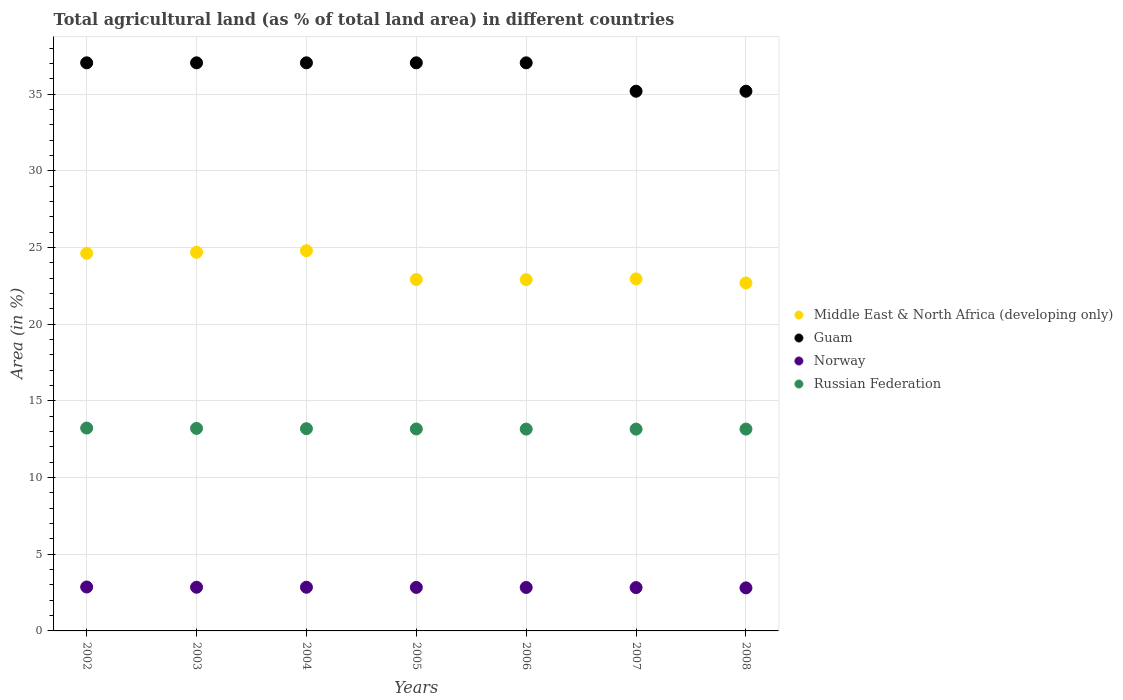How many different coloured dotlines are there?
Keep it short and to the point. 4. Is the number of dotlines equal to the number of legend labels?
Your answer should be compact. Yes. What is the percentage of agricultural land in Middle East & North Africa (developing only) in 2007?
Provide a succinct answer. 22.95. Across all years, what is the maximum percentage of agricultural land in Russian Federation?
Your answer should be compact. 13.23. Across all years, what is the minimum percentage of agricultural land in Guam?
Offer a terse response. 35.19. What is the total percentage of agricultural land in Norway in the graph?
Provide a short and direct response. 19.86. What is the difference between the percentage of agricultural land in Guam in 2003 and the percentage of agricultural land in Middle East & North Africa (developing only) in 2005?
Ensure brevity in your answer.  14.13. What is the average percentage of agricultural land in Middle East & North Africa (developing only) per year?
Offer a terse response. 23.65. In the year 2005, what is the difference between the percentage of agricultural land in Middle East & North Africa (developing only) and percentage of agricultural land in Norway?
Offer a very short reply. 20.07. What is the ratio of the percentage of agricultural land in Middle East & North Africa (developing only) in 2003 to that in 2005?
Provide a short and direct response. 1.08. What is the difference between the highest and the second highest percentage of agricultural land in Norway?
Ensure brevity in your answer.  0.02. What is the difference between the highest and the lowest percentage of agricultural land in Norway?
Your answer should be very brief. 0.06. In how many years, is the percentage of agricultural land in Russian Federation greater than the average percentage of agricultural land in Russian Federation taken over all years?
Your response must be concise. 3. Is the sum of the percentage of agricultural land in Guam in 2003 and 2008 greater than the maximum percentage of agricultural land in Russian Federation across all years?
Ensure brevity in your answer.  Yes. Is it the case that in every year, the sum of the percentage of agricultural land in Russian Federation and percentage of agricultural land in Middle East & North Africa (developing only)  is greater than the percentage of agricultural land in Guam?
Make the answer very short. No. Is the percentage of agricultural land in Norway strictly greater than the percentage of agricultural land in Russian Federation over the years?
Keep it short and to the point. No. How many years are there in the graph?
Your answer should be compact. 7. Are the values on the major ticks of Y-axis written in scientific E-notation?
Offer a very short reply. No. Does the graph contain any zero values?
Keep it short and to the point. No. Does the graph contain grids?
Your response must be concise. Yes. Where does the legend appear in the graph?
Provide a short and direct response. Center right. How many legend labels are there?
Your answer should be very brief. 4. What is the title of the graph?
Give a very brief answer. Total agricultural land (as % of total land area) in different countries. What is the label or title of the Y-axis?
Give a very brief answer. Area (in %). What is the Area (in %) in Middle East & North Africa (developing only) in 2002?
Your answer should be very brief. 24.62. What is the Area (in %) in Guam in 2002?
Provide a succinct answer. 37.04. What is the Area (in %) in Norway in 2002?
Your answer should be compact. 2.86. What is the Area (in %) in Russian Federation in 2002?
Give a very brief answer. 13.23. What is the Area (in %) in Middle East & North Africa (developing only) in 2003?
Give a very brief answer. 24.69. What is the Area (in %) of Guam in 2003?
Provide a short and direct response. 37.04. What is the Area (in %) in Norway in 2003?
Your answer should be very brief. 2.85. What is the Area (in %) in Russian Federation in 2003?
Make the answer very short. 13.2. What is the Area (in %) in Middle East & North Africa (developing only) in 2004?
Offer a very short reply. 24.79. What is the Area (in %) of Guam in 2004?
Provide a succinct answer. 37.04. What is the Area (in %) of Norway in 2004?
Keep it short and to the point. 2.85. What is the Area (in %) of Russian Federation in 2004?
Make the answer very short. 13.18. What is the Area (in %) in Middle East & North Africa (developing only) in 2005?
Provide a short and direct response. 22.91. What is the Area (in %) in Guam in 2005?
Offer a terse response. 37.04. What is the Area (in %) in Norway in 2005?
Your response must be concise. 2.84. What is the Area (in %) of Russian Federation in 2005?
Make the answer very short. 13.17. What is the Area (in %) in Middle East & North Africa (developing only) in 2006?
Ensure brevity in your answer.  22.9. What is the Area (in %) in Guam in 2006?
Offer a terse response. 37.04. What is the Area (in %) of Norway in 2006?
Give a very brief answer. 2.83. What is the Area (in %) of Russian Federation in 2006?
Offer a very short reply. 13.16. What is the Area (in %) in Middle East & North Africa (developing only) in 2007?
Your answer should be compact. 22.95. What is the Area (in %) of Guam in 2007?
Offer a terse response. 35.19. What is the Area (in %) in Norway in 2007?
Give a very brief answer. 2.83. What is the Area (in %) in Russian Federation in 2007?
Your answer should be compact. 13.16. What is the Area (in %) of Middle East & North Africa (developing only) in 2008?
Make the answer very short. 22.68. What is the Area (in %) of Guam in 2008?
Keep it short and to the point. 35.19. What is the Area (in %) in Norway in 2008?
Your answer should be compact. 2.81. What is the Area (in %) of Russian Federation in 2008?
Keep it short and to the point. 13.16. Across all years, what is the maximum Area (in %) in Middle East & North Africa (developing only)?
Your answer should be compact. 24.79. Across all years, what is the maximum Area (in %) in Guam?
Keep it short and to the point. 37.04. Across all years, what is the maximum Area (in %) in Norway?
Your answer should be compact. 2.86. Across all years, what is the maximum Area (in %) of Russian Federation?
Provide a short and direct response. 13.23. Across all years, what is the minimum Area (in %) in Middle East & North Africa (developing only)?
Give a very brief answer. 22.68. Across all years, what is the minimum Area (in %) of Guam?
Give a very brief answer. 35.19. Across all years, what is the minimum Area (in %) in Norway?
Your response must be concise. 2.81. Across all years, what is the minimum Area (in %) of Russian Federation?
Provide a short and direct response. 13.16. What is the total Area (in %) of Middle East & North Africa (developing only) in the graph?
Give a very brief answer. 165.54. What is the total Area (in %) in Guam in the graph?
Your answer should be very brief. 255.56. What is the total Area (in %) of Norway in the graph?
Your answer should be very brief. 19.86. What is the total Area (in %) of Russian Federation in the graph?
Make the answer very short. 92.25. What is the difference between the Area (in %) in Middle East & North Africa (developing only) in 2002 and that in 2003?
Give a very brief answer. -0.07. What is the difference between the Area (in %) in Guam in 2002 and that in 2003?
Offer a very short reply. 0. What is the difference between the Area (in %) of Norway in 2002 and that in 2003?
Ensure brevity in your answer.  0.02. What is the difference between the Area (in %) of Russian Federation in 2002 and that in 2003?
Your answer should be very brief. 0.02. What is the difference between the Area (in %) in Middle East & North Africa (developing only) in 2002 and that in 2004?
Your answer should be very brief. -0.17. What is the difference between the Area (in %) of Guam in 2002 and that in 2004?
Your answer should be compact. 0. What is the difference between the Area (in %) in Norway in 2002 and that in 2004?
Your answer should be compact. 0.02. What is the difference between the Area (in %) of Russian Federation in 2002 and that in 2004?
Ensure brevity in your answer.  0.04. What is the difference between the Area (in %) in Middle East & North Africa (developing only) in 2002 and that in 2005?
Ensure brevity in your answer.  1.71. What is the difference between the Area (in %) of Norway in 2002 and that in 2005?
Offer a terse response. 0.03. What is the difference between the Area (in %) in Russian Federation in 2002 and that in 2005?
Make the answer very short. 0.06. What is the difference between the Area (in %) in Middle East & North Africa (developing only) in 2002 and that in 2006?
Your answer should be compact. 1.72. What is the difference between the Area (in %) of Norway in 2002 and that in 2006?
Make the answer very short. 0.03. What is the difference between the Area (in %) of Russian Federation in 2002 and that in 2006?
Your answer should be compact. 0.07. What is the difference between the Area (in %) of Middle East & North Africa (developing only) in 2002 and that in 2007?
Keep it short and to the point. 1.67. What is the difference between the Area (in %) in Guam in 2002 and that in 2007?
Provide a succinct answer. 1.85. What is the difference between the Area (in %) in Norway in 2002 and that in 2007?
Provide a short and direct response. 0.04. What is the difference between the Area (in %) in Russian Federation in 2002 and that in 2007?
Make the answer very short. 0.07. What is the difference between the Area (in %) in Middle East & North Africa (developing only) in 2002 and that in 2008?
Offer a terse response. 1.93. What is the difference between the Area (in %) of Guam in 2002 and that in 2008?
Your answer should be very brief. 1.85. What is the difference between the Area (in %) of Norway in 2002 and that in 2008?
Make the answer very short. 0.06. What is the difference between the Area (in %) of Russian Federation in 2002 and that in 2008?
Keep it short and to the point. 0.07. What is the difference between the Area (in %) in Middle East & North Africa (developing only) in 2003 and that in 2004?
Your answer should be very brief. -0.1. What is the difference between the Area (in %) of Russian Federation in 2003 and that in 2004?
Your answer should be very brief. 0.02. What is the difference between the Area (in %) in Middle East & North Africa (developing only) in 2003 and that in 2005?
Give a very brief answer. 1.78. What is the difference between the Area (in %) of Guam in 2003 and that in 2005?
Your answer should be very brief. 0. What is the difference between the Area (in %) in Norway in 2003 and that in 2005?
Provide a short and direct response. 0.01. What is the difference between the Area (in %) of Russian Federation in 2003 and that in 2005?
Keep it short and to the point. 0.04. What is the difference between the Area (in %) of Middle East & North Africa (developing only) in 2003 and that in 2006?
Keep it short and to the point. 1.79. What is the difference between the Area (in %) in Guam in 2003 and that in 2006?
Offer a terse response. 0. What is the difference between the Area (in %) in Norway in 2003 and that in 2006?
Your response must be concise. 0.01. What is the difference between the Area (in %) in Russian Federation in 2003 and that in 2006?
Your answer should be very brief. 0.05. What is the difference between the Area (in %) in Middle East & North Africa (developing only) in 2003 and that in 2007?
Offer a terse response. 1.74. What is the difference between the Area (in %) of Guam in 2003 and that in 2007?
Give a very brief answer. 1.85. What is the difference between the Area (in %) in Norway in 2003 and that in 2007?
Make the answer very short. 0.02. What is the difference between the Area (in %) in Russian Federation in 2003 and that in 2007?
Make the answer very short. 0.05. What is the difference between the Area (in %) of Middle East & North Africa (developing only) in 2003 and that in 2008?
Keep it short and to the point. 2. What is the difference between the Area (in %) of Guam in 2003 and that in 2008?
Provide a succinct answer. 1.85. What is the difference between the Area (in %) of Norway in 2003 and that in 2008?
Your answer should be compact. 0.04. What is the difference between the Area (in %) in Russian Federation in 2003 and that in 2008?
Provide a succinct answer. 0.04. What is the difference between the Area (in %) in Middle East & North Africa (developing only) in 2004 and that in 2005?
Keep it short and to the point. 1.88. What is the difference between the Area (in %) in Norway in 2004 and that in 2005?
Your answer should be compact. 0.01. What is the difference between the Area (in %) in Russian Federation in 2004 and that in 2005?
Your answer should be compact. 0.02. What is the difference between the Area (in %) of Middle East & North Africa (developing only) in 2004 and that in 2006?
Offer a terse response. 1.89. What is the difference between the Area (in %) in Guam in 2004 and that in 2006?
Provide a short and direct response. 0. What is the difference between the Area (in %) in Norway in 2004 and that in 2006?
Keep it short and to the point. 0.01. What is the difference between the Area (in %) in Russian Federation in 2004 and that in 2006?
Keep it short and to the point. 0.03. What is the difference between the Area (in %) in Middle East & North Africa (developing only) in 2004 and that in 2007?
Your response must be concise. 1.84. What is the difference between the Area (in %) in Guam in 2004 and that in 2007?
Provide a succinct answer. 1.85. What is the difference between the Area (in %) in Norway in 2004 and that in 2007?
Provide a succinct answer. 0.02. What is the difference between the Area (in %) in Russian Federation in 2004 and that in 2007?
Your answer should be very brief. 0.03. What is the difference between the Area (in %) in Middle East & North Africa (developing only) in 2004 and that in 2008?
Give a very brief answer. 2.1. What is the difference between the Area (in %) of Guam in 2004 and that in 2008?
Your answer should be very brief. 1.85. What is the difference between the Area (in %) of Norway in 2004 and that in 2008?
Offer a terse response. 0.04. What is the difference between the Area (in %) of Russian Federation in 2004 and that in 2008?
Provide a short and direct response. 0.03. What is the difference between the Area (in %) in Middle East & North Africa (developing only) in 2005 and that in 2006?
Give a very brief answer. 0.01. What is the difference between the Area (in %) of Norway in 2005 and that in 2006?
Make the answer very short. 0. What is the difference between the Area (in %) of Russian Federation in 2005 and that in 2006?
Offer a terse response. 0.01. What is the difference between the Area (in %) in Middle East & North Africa (developing only) in 2005 and that in 2007?
Keep it short and to the point. -0.04. What is the difference between the Area (in %) of Guam in 2005 and that in 2007?
Make the answer very short. 1.85. What is the difference between the Area (in %) in Norway in 2005 and that in 2007?
Your answer should be compact. 0.01. What is the difference between the Area (in %) in Russian Federation in 2005 and that in 2007?
Provide a succinct answer. 0.01. What is the difference between the Area (in %) in Middle East & North Africa (developing only) in 2005 and that in 2008?
Provide a short and direct response. 0.23. What is the difference between the Area (in %) of Guam in 2005 and that in 2008?
Keep it short and to the point. 1.85. What is the difference between the Area (in %) in Norway in 2005 and that in 2008?
Give a very brief answer. 0.03. What is the difference between the Area (in %) of Russian Federation in 2005 and that in 2008?
Keep it short and to the point. 0.01. What is the difference between the Area (in %) in Middle East & North Africa (developing only) in 2006 and that in 2007?
Keep it short and to the point. -0.05. What is the difference between the Area (in %) of Guam in 2006 and that in 2007?
Ensure brevity in your answer.  1.85. What is the difference between the Area (in %) of Norway in 2006 and that in 2007?
Your answer should be very brief. 0.01. What is the difference between the Area (in %) in Russian Federation in 2006 and that in 2007?
Your answer should be compact. 0. What is the difference between the Area (in %) in Middle East & North Africa (developing only) in 2006 and that in 2008?
Make the answer very short. 0.22. What is the difference between the Area (in %) in Guam in 2006 and that in 2008?
Provide a short and direct response. 1.85. What is the difference between the Area (in %) of Norway in 2006 and that in 2008?
Offer a very short reply. 0.03. What is the difference between the Area (in %) in Russian Federation in 2006 and that in 2008?
Offer a very short reply. -0. What is the difference between the Area (in %) in Middle East & North Africa (developing only) in 2007 and that in 2008?
Ensure brevity in your answer.  0.27. What is the difference between the Area (in %) in Norway in 2007 and that in 2008?
Your response must be concise. 0.02. What is the difference between the Area (in %) in Russian Federation in 2007 and that in 2008?
Offer a terse response. -0. What is the difference between the Area (in %) in Middle East & North Africa (developing only) in 2002 and the Area (in %) in Guam in 2003?
Offer a very short reply. -12.42. What is the difference between the Area (in %) in Middle East & North Africa (developing only) in 2002 and the Area (in %) in Norway in 2003?
Give a very brief answer. 21.77. What is the difference between the Area (in %) of Middle East & North Africa (developing only) in 2002 and the Area (in %) of Russian Federation in 2003?
Offer a terse response. 11.41. What is the difference between the Area (in %) in Guam in 2002 and the Area (in %) in Norway in 2003?
Give a very brief answer. 34.19. What is the difference between the Area (in %) in Guam in 2002 and the Area (in %) in Russian Federation in 2003?
Your answer should be compact. 23.83. What is the difference between the Area (in %) in Norway in 2002 and the Area (in %) in Russian Federation in 2003?
Keep it short and to the point. -10.34. What is the difference between the Area (in %) in Middle East & North Africa (developing only) in 2002 and the Area (in %) in Guam in 2004?
Ensure brevity in your answer.  -12.42. What is the difference between the Area (in %) in Middle East & North Africa (developing only) in 2002 and the Area (in %) in Norway in 2004?
Offer a terse response. 21.77. What is the difference between the Area (in %) of Middle East & North Africa (developing only) in 2002 and the Area (in %) of Russian Federation in 2004?
Offer a very short reply. 11.43. What is the difference between the Area (in %) in Guam in 2002 and the Area (in %) in Norway in 2004?
Offer a very short reply. 34.19. What is the difference between the Area (in %) of Guam in 2002 and the Area (in %) of Russian Federation in 2004?
Keep it short and to the point. 23.85. What is the difference between the Area (in %) in Norway in 2002 and the Area (in %) in Russian Federation in 2004?
Your answer should be compact. -10.32. What is the difference between the Area (in %) of Middle East & North Africa (developing only) in 2002 and the Area (in %) of Guam in 2005?
Make the answer very short. -12.42. What is the difference between the Area (in %) of Middle East & North Africa (developing only) in 2002 and the Area (in %) of Norway in 2005?
Offer a terse response. 21.78. What is the difference between the Area (in %) in Middle East & North Africa (developing only) in 2002 and the Area (in %) in Russian Federation in 2005?
Your response must be concise. 11.45. What is the difference between the Area (in %) of Guam in 2002 and the Area (in %) of Norway in 2005?
Offer a terse response. 34.2. What is the difference between the Area (in %) of Guam in 2002 and the Area (in %) of Russian Federation in 2005?
Your answer should be compact. 23.87. What is the difference between the Area (in %) of Norway in 2002 and the Area (in %) of Russian Federation in 2005?
Your answer should be compact. -10.3. What is the difference between the Area (in %) in Middle East & North Africa (developing only) in 2002 and the Area (in %) in Guam in 2006?
Offer a very short reply. -12.42. What is the difference between the Area (in %) in Middle East & North Africa (developing only) in 2002 and the Area (in %) in Norway in 2006?
Provide a short and direct response. 21.78. What is the difference between the Area (in %) of Middle East & North Africa (developing only) in 2002 and the Area (in %) of Russian Federation in 2006?
Your response must be concise. 11.46. What is the difference between the Area (in %) in Guam in 2002 and the Area (in %) in Norway in 2006?
Offer a very short reply. 34.2. What is the difference between the Area (in %) of Guam in 2002 and the Area (in %) of Russian Federation in 2006?
Give a very brief answer. 23.88. What is the difference between the Area (in %) in Norway in 2002 and the Area (in %) in Russian Federation in 2006?
Your response must be concise. -10.29. What is the difference between the Area (in %) in Middle East & North Africa (developing only) in 2002 and the Area (in %) in Guam in 2007?
Provide a short and direct response. -10.57. What is the difference between the Area (in %) of Middle East & North Africa (developing only) in 2002 and the Area (in %) of Norway in 2007?
Make the answer very short. 21.79. What is the difference between the Area (in %) in Middle East & North Africa (developing only) in 2002 and the Area (in %) in Russian Federation in 2007?
Provide a short and direct response. 11.46. What is the difference between the Area (in %) of Guam in 2002 and the Area (in %) of Norway in 2007?
Give a very brief answer. 34.21. What is the difference between the Area (in %) of Guam in 2002 and the Area (in %) of Russian Federation in 2007?
Your response must be concise. 23.88. What is the difference between the Area (in %) in Norway in 2002 and the Area (in %) in Russian Federation in 2007?
Make the answer very short. -10.29. What is the difference between the Area (in %) of Middle East & North Africa (developing only) in 2002 and the Area (in %) of Guam in 2008?
Your answer should be compact. -10.57. What is the difference between the Area (in %) of Middle East & North Africa (developing only) in 2002 and the Area (in %) of Norway in 2008?
Give a very brief answer. 21.81. What is the difference between the Area (in %) in Middle East & North Africa (developing only) in 2002 and the Area (in %) in Russian Federation in 2008?
Your answer should be very brief. 11.46. What is the difference between the Area (in %) in Guam in 2002 and the Area (in %) in Norway in 2008?
Offer a terse response. 34.23. What is the difference between the Area (in %) in Guam in 2002 and the Area (in %) in Russian Federation in 2008?
Provide a short and direct response. 23.88. What is the difference between the Area (in %) in Norway in 2002 and the Area (in %) in Russian Federation in 2008?
Give a very brief answer. -10.29. What is the difference between the Area (in %) in Middle East & North Africa (developing only) in 2003 and the Area (in %) in Guam in 2004?
Give a very brief answer. -12.35. What is the difference between the Area (in %) in Middle East & North Africa (developing only) in 2003 and the Area (in %) in Norway in 2004?
Your response must be concise. 21.84. What is the difference between the Area (in %) of Middle East & North Africa (developing only) in 2003 and the Area (in %) of Russian Federation in 2004?
Your response must be concise. 11.5. What is the difference between the Area (in %) of Guam in 2003 and the Area (in %) of Norway in 2004?
Make the answer very short. 34.19. What is the difference between the Area (in %) of Guam in 2003 and the Area (in %) of Russian Federation in 2004?
Offer a terse response. 23.85. What is the difference between the Area (in %) in Norway in 2003 and the Area (in %) in Russian Federation in 2004?
Provide a short and direct response. -10.34. What is the difference between the Area (in %) in Middle East & North Africa (developing only) in 2003 and the Area (in %) in Guam in 2005?
Offer a very short reply. -12.35. What is the difference between the Area (in %) of Middle East & North Africa (developing only) in 2003 and the Area (in %) of Norway in 2005?
Ensure brevity in your answer.  21.85. What is the difference between the Area (in %) in Middle East & North Africa (developing only) in 2003 and the Area (in %) in Russian Federation in 2005?
Provide a succinct answer. 11.52. What is the difference between the Area (in %) in Guam in 2003 and the Area (in %) in Norway in 2005?
Provide a short and direct response. 34.2. What is the difference between the Area (in %) of Guam in 2003 and the Area (in %) of Russian Federation in 2005?
Your response must be concise. 23.87. What is the difference between the Area (in %) in Norway in 2003 and the Area (in %) in Russian Federation in 2005?
Provide a short and direct response. -10.32. What is the difference between the Area (in %) in Middle East & North Africa (developing only) in 2003 and the Area (in %) in Guam in 2006?
Offer a very short reply. -12.35. What is the difference between the Area (in %) of Middle East & North Africa (developing only) in 2003 and the Area (in %) of Norway in 2006?
Provide a short and direct response. 21.85. What is the difference between the Area (in %) in Middle East & North Africa (developing only) in 2003 and the Area (in %) in Russian Federation in 2006?
Provide a succinct answer. 11.53. What is the difference between the Area (in %) of Guam in 2003 and the Area (in %) of Norway in 2006?
Provide a succinct answer. 34.2. What is the difference between the Area (in %) in Guam in 2003 and the Area (in %) in Russian Federation in 2006?
Offer a very short reply. 23.88. What is the difference between the Area (in %) of Norway in 2003 and the Area (in %) of Russian Federation in 2006?
Your response must be concise. -10.31. What is the difference between the Area (in %) in Middle East & North Africa (developing only) in 2003 and the Area (in %) in Guam in 2007?
Give a very brief answer. -10.5. What is the difference between the Area (in %) of Middle East & North Africa (developing only) in 2003 and the Area (in %) of Norway in 2007?
Provide a short and direct response. 21.86. What is the difference between the Area (in %) in Middle East & North Africa (developing only) in 2003 and the Area (in %) in Russian Federation in 2007?
Keep it short and to the point. 11.53. What is the difference between the Area (in %) of Guam in 2003 and the Area (in %) of Norway in 2007?
Your response must be concise. 34.21. What is the difference between the Area (in %) of Guam in 2003 and the Area (in %) of Russian Federation in 2007?
Offer a very short reply. 23.88. What is the difference between the Area (in %) of Norway in 2003 and the Area (in %) of Russian Federation in 2007?
Provide a short and direct response. -10.31. What is the difference between the Area (in %) of Middle East & North Africa (developing only) in 2003 and the Area (in %) of Guam in 2008?
Your answer should be very brief. -10.5. What is the difference between the Area (in %) of Middle East & North Africa (developing only) in 2003 and the Area (in %) of Norway in 2008?
Provide a short and direct response. 21.88. What is the difference between the Area (in %) in Middle East & North Africa (developing only) in 2003 and the Area (in %) in Russian Federation in 2008?
Give a very brief answer. 11.53. What is the difference between the Area (in %) in Guam in 2003 and the Area (in %) in Norway in 2008?
Provide a succinct answer. 34.23. What is the difference between the Area (in %) of Guam in 2003 and the Area (in %) of Russian Federation in 2008?
Ensure brevity in your answer.  23.88. What is the difference between the Area (in %) in Norway in 2003 and the Area (in %) in Russian Federation in 2008?
Provide a succinct answer. -10.31. What is the difference between the Area (in %) of Middle East & North Africa (developing only) in 2004 and the Area (in %) of Guam in 2005?
Offer a terse response. -12.25. What is the difference between the Area (in %) of Middle East & North Africa (developing only) in 2004 and the Area (in %) of Norway in 2005?
Ensure brevity in your answer.  21.95. What is the difference between the Area (in %) in Middle East & North Africa (developing only) in 2004 and the Area (in %) in Russian Federation in 2005?
Offer a terse response. 11.62. What is the difference between the Area (in %) of Guam in 2004 and the Area (in %) of Norway in 2005?
Your answer should be compact. 34.2. What is the difference between the Area (in %) in Guam in 2004 and the Area (in %) in Russian Federation in 2005?
Provide a succinct answer. 23.87. What is the difference between the Area (in %) in Norway in 2004 and the Area (in %) in Russian Federation in 2005?
Provide a succinct answer. -10.32. What is the difference between the Area (in %) of Middle East & North Africa (developing only) in 2004 and the Area (in %) of Guam in 2006?
Give a very brief answer. -12.25. What is the difference between the Area (in %) of Middle East & North Africa (developing only) in 2004 and the Area (in %) of Norway in 2006?
Offer a terse response. 21.95. What is the difference between the Area (in %) of Middle East & North Africa (developing only) in 2004 and the Area (in %) of Russian Federation in 2006?
Keep it short and to the point. 11.63. What is the difference between the Area (in %) of Guam in 2004 and the Area (in %) of Norway in 2006?
Make the answer very short. 34.2. What is the difference between the Area (in %) of Guam in 2004 and the Area (in %) of Russian Federation in 2006?
Keep it short and to the point. 23.88. What is the difference between the Area (in %) in Norway in 2004 and the Area (in %) in Russian Federation in 2006?
Give a very brief answer. -10.31. What is the difference between the Area (in %) of Middle East & North Africa (developing only) in 2004 and the Area (in %) of Guam in 2007?
Make the answer very short. -10.4. What is the difference between the Area (in %) of Middle East & North Africa (developing only) in 2004 and the Area (in %) of Norway in 2007?
Offer a terse response. 21.96. What is the difference between the Area (in %) of Middle East & North Africa (developing only) in 2004 and the Area (in %) of Russian Federation in 2007?
Your answer should be compact. 11.63. What is the difference between the Area (in %) of Guam in 2004 and the Area (in %) of Norway in 2007?
Offer a terse response. 34.21. What is the difference between the Area (in %) of Guam in 2004 and the Area (in %) of Russian Federation in 2007?
Give a very brief answer. 23.88. What is the difference between the Area (in %) of Norway in 2004 and the Area (in %) of Russian Federation in 2007?
Make the answer very short. -10.31. What is the difference between the Area (in %) in Middle East & North Africa (developing only) in 2004 and the Area (in %) in Guam in 2008?
Your answer should be very brief. -10.4. What is the difference between the Area (in %) in Middle East & North Africa (developing only) in 2004 and the Area (in %) in Norway in 2008?
Your answer should be compact. 21.98. What is the difference between the Area (in %) in Middle East & North Africa (developing only) in 2004 and the Area (in %) in Russian Federation in 2008?
Give a very brief answer. 11.63. What is the difference between the Area (in %) in Guam in 2004 and the Area (in %) in Norway in 2008?
Your answer should be very brief. 34.23. What is the difference between the Area (in %) of Guam in 2004 and the Area (in %) of Russian Federation in 2008?
Provide a succinct answer. 23.88. What is the difference between the Area (in %) of Norway in 2004 and the Area (in %) of Russian Federation in 2008?
Offer a very short reply. -10.31. What is the difference between the Area (in %) in Middle East & North Africa (developing only) in 2005 and the Area (in %) in Guam in 2006?
Offer a very short reply. -14.13. What is the difference between the Area (in %) in Middle East & North Africa (developing only) in 2005 and the Area (in %) in Norway in 2006?
Your answer should be compact. 20.08. What is the difference between the Area (in %) of Middle East & North Africa (developing only) in 2005 and the Area (in %) of Russian Federation in 2006?
Make the answer very short. 9.75. What is the difference between the Area (in %) in Guam in 2005 and the Area (in %) in Norway in 2006?
Your response must be concise. 34.2. What is the difference between the Area (in %) in Guam in 2005 and the Area (in %) in Russian Federation in 2006?
Keep it short and to the point. 23.88. What is the difference between the Area (in %) in Norway in 2005 and the Area (in %) in Russian Federation in 2006?
Your answer should be compact. -10.32. What is the difference between the Area (in %) in Middle East & North Africa (developing only) in 2005 and the Area (in %) in Guam in 2007?
Your response must be concise. -12.27. What is the difference between the Area (in %) in Middle East & North Africa (developing only) in 2005 and the Area (in %) in Norway in 2007?
Provide a short and direct response. 20.09. What is the difference between the Area (in %) in Middle East & North Africa (developing only) in 2005 and the Area (in %) in Russian Federation in 2007?
Ensure brevity in your answer.  9.76. What is the difference between the Area (in %) of Guam in 2005 and the Area (in %) of Norway in 2007?
Your answer should be compact. 34.21. What is the difference between the Area (in %) of Guam in 2005 and the Area (in %) of Russian Federation in 2007?
Make the answer very short. 23.88. What is the difference between the Area (in %) of Norway in 2005 and the Area (in %) of Russian Federation in 2007?
Your response must be concise. -10.32. What is the difference between the Area (in %) in Middle East & North Africa (developing only) in 2005 and the Area (in %) in Guam in 2008?
Offer a very short reply. -12.27. What is the difference between the Area (in %) of Middle East & North Africa (developing only) in 2005 and the Area (in %) of Norway in 2008?
Provide a succinct answer. 20.11. What is the difference between the Area (in %) in Middle East & North Africa (developing only) in 2005 and the Area (in %) in Russian Federation in 2008?
Keep it short and to the point. 9.75. What is the difference between the Area (in %) in Guam in 2005 and the Area (in %) in Norway in 2008?
Your answer should be very brief. 34.23. What is the difference between the Area (in %) of Guam in 2005 and the Area (in %) of Russian Federation in 2008?
Ensure brevity in your answer.  23.88. What is the difference between the Area (in %) in Norway in 2005 and the Area (in %) in Russian Federation in 2008?
Ensure brevity in your answer.  -10.32. What is the difference between the Area (in %) in Middle East & North Africa (developing only) in 2006 and the Area (in %) in Guam in 2007?
Offer a very short reply. -12.28. What is the difference between the Area (in %) of Middle East & North Africa (developing only) in 2006 and the Area (in %) of Norway in 2007?
Keep it short and to the point. 20.08. What is the difference between the Area (in %) in Middle East & North Africa (developing only) in 2006 and the Area (in %) in Russian Federation in 2007?
Provide a succinct answer. 9.75. What is the difference between the Area (in %) in Guam in 2006 and the Area (in %) in Norway in 2007?
Give a very brief answer. 34.21. What is the difference between the Area (in %) of Guam in 2006 and the Area (in %) of Russian Federation in 2007?
Your response must be concise. 23.88. What is the difference between the Area (in %) in Norway in 2006 and the Area (in %) in Russian Federation in 2007?
Offer a very short reply. -10.32. What is the difference between the Area (in %) in Middle East & North Africa (developing only) in 2006 and the Area (in %) in Guam in 2008?
Provide a short and direct response. -12.28. What is the difference between the Area (in %) of Middle East & North Africa (developing only) in 2006 and the Area (in %) of Norway in 2008?
Keep it short and to the point. 20.1. What is the difference between the Area (in %) of Middle East & North Africa (developing only) in 2006 and the Area (in %) of Russian Federation in 2008?
Give a very brief answer. 9.74. What is the difference between the Area (in %) in Guam in 2006 and the Area (in %) in Norway in 2008?
Offer a terse response. 34.23. What is the difference between the Area (in %) in Guam in 2006 and the Area (in %) in Russian Federation in 2008?
Offer a very short reply. 23.88. What is the difference between the Area (in %) of Norway in 2006 and the Area (in %) of Russian Federation in 2008?
Your answer should be very brief. -10.32. What is the difference between the Area (in %) in Middle East & North Africa (developing only) in 2007 and the Area (in %) in Guam in 2008?
Ensure brevity in your answer.  -12.23. What is the difference between the Area (in %) of Middle East & North Africa (developing only) in 2007 and the Area (in %) of Norway in 2008?
Ensure brevity in your answer.  20.14. What is the difference between the Area (in %) in Middle East & North Africa (developing only) in 2007 and the Area (in %) in Russian Federation in 2008?
Keep it short and to the point. 9.79. What is the difference between the Area (in %) of Guam in 2007 and the Area (in %) of Norway in 2008?
Your answer should be compact. 32.38. What is the difference between the Area (in %) in Guam in 2007 and the Area (in %) in Russian Federation in 2008?
Your answer should be compact. 22.03. What is the difference between the Area (in %) in Norway in 2007 and the Area (in %) in Russian Federation in 2008?
Your answer should be compact. -10.33. What is the average Area (in %) in Middle East & North Africa (developing only) per year?
Provide a short and direct response. 23.65. What is the average Area (in %) of Guam per year?
Ensure brevity in your answer.  36.51. What is the average Area (in %) of Norway per year?
Offer a terse response. 2.84. What is the average Area (in %) of Russian Federation per year?
Make the answer very short. 13.18. In the year 2002, what is the difference between the Area (in %) in Middle East & North Africa (developing only) and Area (in %) in Guam?
Make the answer very short. -12.42. In the year 2002, what is the difference between the Area (in %) in Middle East & North Africa (developing only) and Area (in %) in Norway?
Make the answer very short. 21.75. In the year 2002, what is the difference between the Area (in %) in Middle East & North Africa (developing only) and Area (in %) in Russian Federation?
Ensure brevity in your answer.  11.39. In the year 2002, what is the difference between the Area (in %) in Guam and Area (in %) in Norway?
Ensure brevity in your answer.  34.17. In the year 2002, what is the difference between the Area (in %) of Guam and Area (in %) of Russian Federation?
Make the answer very short. 23.81. In the year 2002, what is the difference between the Area (in %) of Norway and Area (in %) of Russian Federation?
Your answer should be very brief. -10.36. In the year 2003, what is the difference between the Area (in %) in Middle East & North Africa (developing only) and Area (in %) in Guam?
Your answer should be compact. -12.35. In the year 2003, what is the difference between the Area (in %) in Middle East & North Africa (developing only) and Area (in %) in Norway?
Keep it short and to the point. 21.84. In the year 2003, what is the difference between the Area (in %) of Middle East & North Africa (developing only) and Area (in %) of Russian Federation?
Provide a short and direct response. 11.48. In the year 2003, what is the difference between the Area (in %) in Guam and Area (in %) in Norway?
Offer a terse response. 34.19. In the year 2003, what is the difference between the Area (in %) in Guam and Area (in %) in Russian Federation?
Give a very brief answer. 23.83. In the year 2003, what is the difference between the Area (in %) of Norway and Area (in %) of Russian Federation?
Offer a very short reply. -10.36. In the year 2004, what is the difference between the Area (in %) in Middle East & North Africa (developing only) and Area (in %) in Guam?
Provide a succinct answer. -12.25. In the year 2004, what is the difference between the Area (in %) in Middle East & North Africa (developing only) and Area (in %) in Norway?
Offer a very short reply. 21.94. In the year 2004, what is the difference between the Area (in %) in Middle East & North Africa (developing only) and Area (in %) in Russian Federation?
Your answer should be compact. 11.6. In the year 2004, what is the difference between the Area (in %) of Guam and Area (in %) of Norway?
Make the answer very short. 34.19. In the year 2004, what is the difference between the Area (in %) in Guam and Area (in %) in Russian Federation?
Your response must be concise. 23.85. In the year 2004, what is the difference between the Area (in %) in Norway and Area (in %) in Russian Federation?
Your response must be concise. -10.34. In the year 2005, what is the difference between the Area (in %) of Middle East & North Africa (developing only) and Area (in %) of Guam?
Ensure brevity in your answer.  -14.13. In the year 2005, what is the difference between the Area (in %) of Middle East & North Africa (developing only) and Area (in %) of Norway?
Offer a very short reply. 20.07. In the year 2005, what is the difference between the Area (in %) in Middle East & North Africa (developing only) and Area (in %) in Russian Federation?
Keep it short and to the point. 9.75. In the year 2005, what is the difference between the Area (in %) of Guam and Area (in %) of Norway?
Offer a terse response. 34.2. In the year 2005, what is the difference between the Area (in %) in Guam and Area (in %) in Russian Federation?
Give a very brief answer. 23.87. In the year 2005, what is the difference between the Area (in %) of Norway and Area (in %) of Russian Federation?
Your answer should be compact. -10.33. In the year 2006, what is the difference between the Area (in %) in Middle East & North Africa (developing only) and Area (in %) in Guam?
Provide a short and direct response. -14.14. In the year 2006, what is the difference between the Area (in %) of Middle East & North Africa (developing only) and Area (in %) of Norway?
Offer a very short reply. 20.07. In the year 2006, what is the difference between the Area (in %) in Middle East & North Africa (developing only) and Area (in %) in Russian Federation?
Your answer should be compact. 9.74. In the year 2006, what is the difference between the Area (in %) in Guam and Area (in %) in Norway?
Offer a terse response. 34.2. In the year 2006, what is the difference between the Area (in %) of Guam and Area (in %) of Russian Federation?
Provide a succinct answer. 23.88. In the year 2006, what is the difference between the Area (in %) in Norway and Area (in %) in Russian Federation?
Provide a succinct answer. -10.32. In the year 2007, what is the difference between the Area (in %) in Middle East & North Africa (developing only) and Area (in %) in Guam?
Your response must be concise. -12.23. In the year 2007, what is the difference between the Area (in %) in Middle East & North Africa (developing only) and Area (in %) in Norway?
Ensure brevity in your answer.  20.12. In the year 2007, what is the difference between the Area (in %) in Middle East & North Africa (developing only) and Area (in %) in Russian Federation?
Your answer should be very brief. 9.79. In the year 2007, what is the difference between the Area (in %) in Guam and Area (in %) in Norway?
Make the answer very short. 32.36. In the year 2007, what is the difference between the Area (in %) in Guam and Area (in %) in Russian Federation?
Your response must be concise. 22.03. In the year 2007, what is the difference between the Area (in %) of Norway and Area (in %) of Russian Federation?
Offer a terse response. -10.33. In the year 2008, what is the difference between the Area (in %) of Middle East & North Africa (developing only) and Area (in %) of Guam?
Provide a succinct answer. -12.5. In the year 2008, what is the difference between the Area (in %) of Middle East & North Africa (developing only) and Area (in %) of Norway?
Give a very brief answer. 19.88. In the year 2008, what is the difference between the Area (in %) of Middle East & North Africa (developing only) and Area (in %) of Russian Federation?
Provide a short and direct response. 9.53. In the year 2008, what is the difference between the Area (in %) of Guam and Area (in %) of Norway?
Your response must be concise. 32.38. In the year 2008, what is the difference between the Area (in %) in Guam and Area (in %) in Russian Federation?
Your answer should be very brief. 22.03. In the year 2008, what is the difference between the Area (in %) in Norway and Area (in %) in Russian Federation?
Offer a very short reply. -10.35. What is the ratio of the Area (in %) of Middle East & North Africa (developing only) in 2002 to that in 2003?
Your response must be concise. 1. What is the ratio of the Area (in %) in Middle East & North Africa (developing only) in 2002 to that in 2004?
Provide a short and direct response. 0.99. What is the ratio of the Area (in %) of Guam in 2002 to that in 2004?
Provide a succinct answer. 1. What is the ratio of the Area (in %) in Middle East & North Africa (developing only) in 2002 to that in 2005?
Provide a short and direct response. 1.07. What is the ratio of the Area (in %) of Norway in 2002 to that in 2005?
Provide a short and direct response. 1.01. What is the ratio of the Area (in %) of Russian Federation in 2002 to that in 2005?
Your answer should be very brief. 1. What is the ratio of the Area (in %) in Middle East & North Africa (developing only) in 2002 to that in 2006?
Offer a terse response. 1.07. What is the ratio of the Area (in %) in Norway in 2002 to that in 2006?
Make the answer very short. 1.01. What is the ratio of the Area (in %) of Middle East & North Africa (developing only) in 2002 to that in 2007?
Provide a short and direct response. 1.07. What is the ratio of the Area (in %) in Guam in 2002 to that in 2007?
Offer a very short reply. 1.05. What is the ratio of the Area (in %) of Norway in 2002 to that in 2007?
Provide a succinct answer. 1.01. What is the ratio of the Area (in %) of Russian Federation in 2002 to that in 2007?
Your answer should be very brief. 1.01. What is the ratio of the Area (in %) of Middle East & North Africa (developing only) in 2002 to that in 2008?
Provide a succinct answer. 1.09. What is the ratio of the Area (in %) of Guam in 2002 to that in 2008?
Provide a succinct answer. 1.05. What is the ratio of the Area (in %) of Norway in 2002 to that in 2008?
Provide a short and direct response. 1.02. What is the ratio of the Area (in %) in Russian Federation in 2002 to that in 2008?
Your answer should be very brief. 1.01. What is the ratio of the Area (in %) in Middle East & North Africa (developing only) in 2003 to that in 2005?
Your response must be concise. 1.08. What is the ratio of the Area (in %) of Guam in 2003 to that in 2005?
Provide a succinct answer. 1. What is the ratio of the Area (in %) in Norway in 2003 to that in 2005?
Your answer should be very brief. 1. What is the ratio of the Area (in %) in Russian Federation in 2003 to that in 2005?
Your answer should be very brief. 1. What is the ratio of the Area (in %) of Middle East & North Africa (developing only) in 2003 to that in 2006?
Your answer should be very brief. 1.08. What is the ratio of the Area (in %) of Norway in 2003 to that in 2006?
Ensure brevity in your answer.  1. What is the ratio of the Area (in %) in Russian Federation in 2003 to that in 2006?
Your response must be concise. 1. What is the ratio of the Area (in %) in Middle East & North Africa (developing only) in 2003 to that in 2007?
Give a very brief answer. 1.08. What is the ratio of the Area (in %) in Guam in 2003 to that in 2007?
Make the answer very short. 1.05. What is the ratio of the Area (in %) in Norway in 2003 to that in 2007?
Make the answer very short. 1.01. What is the ratio of the Area (in %) in Middle East & North Africa (developing only) in 2003 to that in 2008?
Provide a succinct answer. 1.09. What is the ratio of the Area (in %) in Guam in 2003 to that in 2008?
Keep it short and to the point. 1.05. What is the ratio of the Area (in %) of Norway in 2003 to that in 2008?
Offer a terse response. 1.01. What is the ratio of the Area (in %) in Russian Federation in 2003 to that in 2008?
Your answer should be very brief. 1. What is the ratio of the Area (in %) of Middle East & North Africa (developing only) in 2004 to that in 2005?
Make the answer very short. 1.08. What is the ratio of the Area (in %) in Guam in 2004 to that in 2005?
Your response must be concise. 1. What is the ratio of the Area (in %) in Norway in 2004 to that in 2005?
Your response must be concise. 1. What is the ratio of the Area (in %) in Middle East & North Africa (developing only) in 2004 to that in 2006?
Keep it short and to the point. 1.08. What is the ratio of the Area (in %) of Russian Federation in 2004 to that in 2006?
Offer a terse response. 1. What is the ratio of the Area (in %) of Middle East & North Africa (developing only) in 2004 to that in 2007?
Keep it short and to the point. 1.08. What is the ratio of the Area (in %) of Guam in 2004 to that in 2007?
Your answer should be compact. 1.05. What is the ratio of the Area (in %) in Middle East & North Africa (developing only) in 2004 to that in 2008?
Ensure brevity in your answer.  1.09. What is the ratio of the Area (in %) in Guam in 2004 to that in 2008?
Give a very brief answer. 1.05. What is the ratio of the Area (in %) of Norway in 2004 to that in 2008?
Keep it short and to the point. 1.01. What is the ratio of the Area (in %) in Russian Federation in 2005 to that in 2006?
Offer a terse response. 1. What is the ratio of the Area (in %) in Guam in 2005 to that in 2007?
Provide a short and direct response. 1.05. What is the ratio of the Area (in %) in Russian Federation in 2005 to that in 2007?
Make the answer very short. 1. What is the ratio of the Area (in %) in Middle East & North Africa (developing only) in 2005 to that in 2008?
Offer a very short reply. 1.01. What is the ratio of the Area (in %) of Guam in 2005 to that in 2008?
Your response must be concise. 1.05. What is the ratio of the Area (in %) in Norway in 2005 to that in 2008?
Your answer should be very brief. 1.01. What is the ratio of the Area (in %) of Guam in 2006 to that in 2007?
Keep it short and to the point. 1.05. What is the ratio of the Area (in %) in Russian Federation in 2006 to that in 2007?
Give a very brief answer. 1. What is the ratio of the Area (in %) in Middle East & North Africa (developing only) in 2006 to that in 2008?
Your answer should be very brief. 1.01. What is the ratio of the Area (in %) in Guam in 2006 to that in 2008?
Your response must be concise. 1.05. What is the ratio of the Area (in %) of Middle East & North Africa (developing only) in 2007 to that in 2008?
Make the answer very short. 1.01. What is the ratio of the Area (in %) of Guam in 2007 to that in 2008?
Your answer should be very brief. 1. What is the ratio of the Area (in %) in Russian Federation in 2007 to that in 2008?
Ensure brevity in your answer.  1. What is the difference between the highest and the second highest Area (in %) of Middle East & North Africa (developing only)?
Provide a short and direct response. 0.1. What is the difference between the highest and the second highest Area (in %) in Norway?
Ensure brevity in your answer.  0.02. What is the difference between the highest and the second highest Area (in %) of Russian Federation?
Your response must be concise. 0.02. What is the difference between the highest and the lowest Area (in %) of Middle East & North Africa (developing only)?
Your answer should be very brief. 2.1. What is the difference between the highest and the lowest Area (in %) of Guam?
Make the answer very short. 1.85. What is the difference between the highest and the lowest Area (in %) in Norway?
Offer a terse response. 0.06. What is the difference between the highest and the lowest Area (in %) in Russian Federation?
Provide a succinct answer. 0.07. 